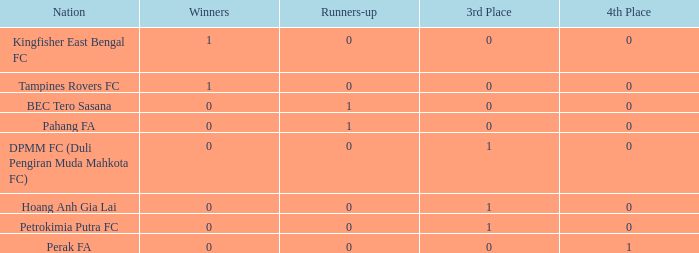Determine the typical 3rd spot with victors of 0, 4th spot of 0, and nation of pahang fa. 0.0. Can you give me this table as a dict? {'header': ['Nation', 'Winners', 'Runners-up', '3rd Place', '4th Place'], 'rows': [['Kingfisher East Bengal FC', '1', '0', '0', '0'], ['Tampines Rovers FC', '1', '0', '0', '0'], ['BEC Tero Sasana', '0', '1', '0', '0'], ['Pahang FA', '0', '1', '0', '0'], ['DPMM FC (Duli Pengiran Muda Mahkota FC)', '0', '0', '1', '0'], ['Hoang Anh Gia Lai', '0', '0', '1', '0'], ['Petrokimia Putra FC', '0', '0', '1', '0'], ['Perak FA', '0', '0', '0', '1']]} 